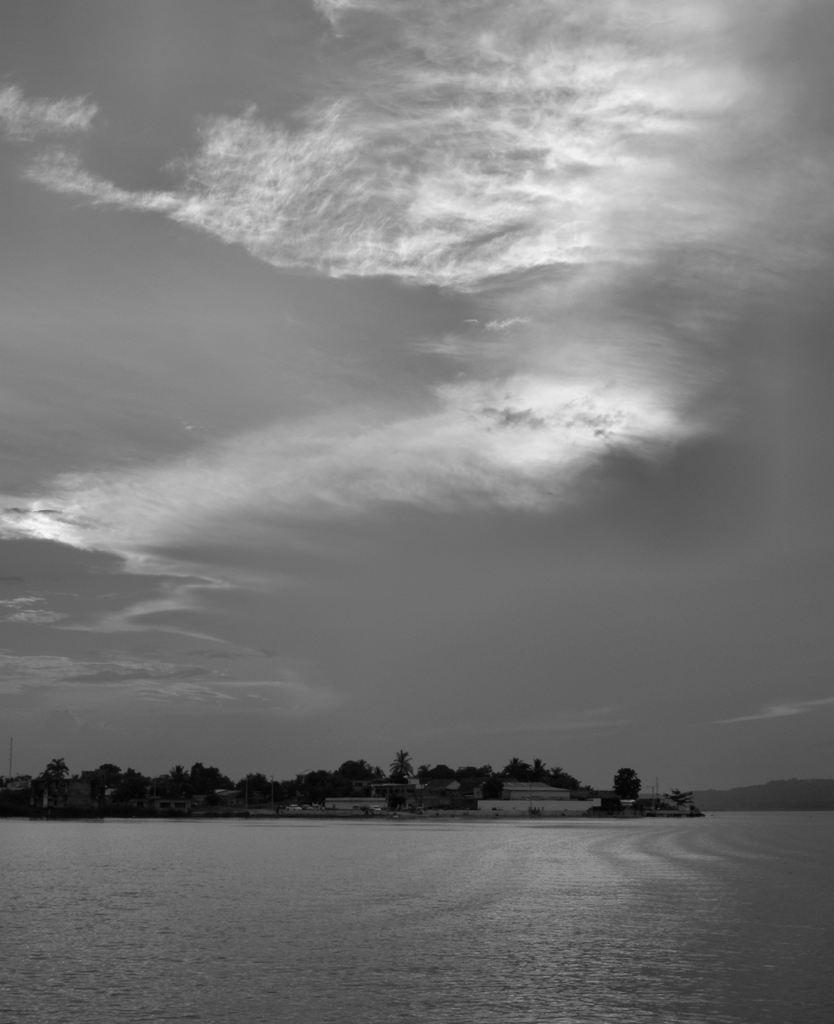What is located at the bottom of the image? There is water at the bottom of the image. What can be seen in the middle of the image? There are trees and houses in the middle of the image. What is visible at the top of the image? The sky is visible at the top of the image. How many elbows can be seen in the image? There are no elbows present in the image. What type of fruit is being crushed in the image? There is no fruit being crushed in the image. 